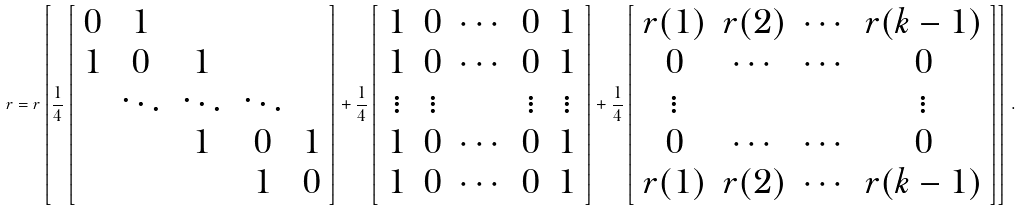<formula> <loc_0><loc_0><loc_500><loc_500>r = r \left [ \frac { 1 } { 4 } \left [ \begin{array} { c c c c c } 0 & 1 & & & \\ 1 & 0 & 1 & & \\ & \ddots & \ddots & \ddots & \\ & & 1 & 0 & 1 \\ & & & 1 & 0 \end{array} \right ] + \frac { 1 } { 4 } \left [ \begin{array} { c c c c c } 1 & 0 & \cdots & 0 & 1 \\ 1 & 0 & \cdots & 0 & 1 \\ \vdots & \vdots & & \vdots & \vdots \\ 1 & 0 & \cdots & 0 & 1 \\ 1 & 0 & \cdots & 0 & 1 \end{array} \right ] + \frac { 1 } { 4 } \left [ \begin{array} { c c c c } r ( 1 ) & r ( 2 ) & \cdots & r ( k - 1 ) \\ 0 & \cdots & \cdots & 0 \\ \vdots & & & \vdots \\ 0 & \cdots & \cdots & 0 \\ r ( 1 ) & r ( 2 ) & \cdots & r ( k - 1 ) \end{array} \right ] \right ] \, .</formula> 